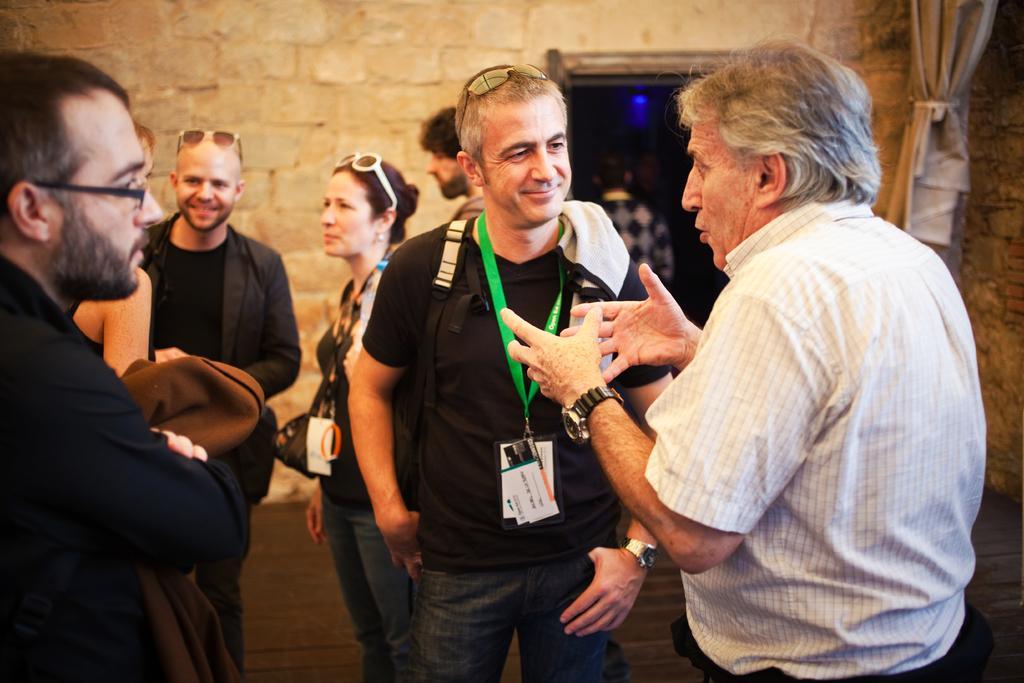Could you give a brief overview of what you see in this image? In this picture we can see a group of people with ID cards standing on the ground and talking to each other. In the background, we can see a stone wall & a door with a curtain. 